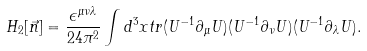Convert formula to latex. <formula><loc_0><loc_0><loc_500><loc_500>H _ { 2 } [ \vec { n } ] = \frac { \epsilon ^ { \mu \nu \lambda } } { 2 4 \pi ^ { 2 } } \int d ^ { 3 } x t r ( U ^ { - 1 } \partial _ { \mu } U ) ( U ^ { - 1 } \partial _ { \nu } U ) ( U ^ { - 1 } \partial _ { \lambda } U ) .</formula> 